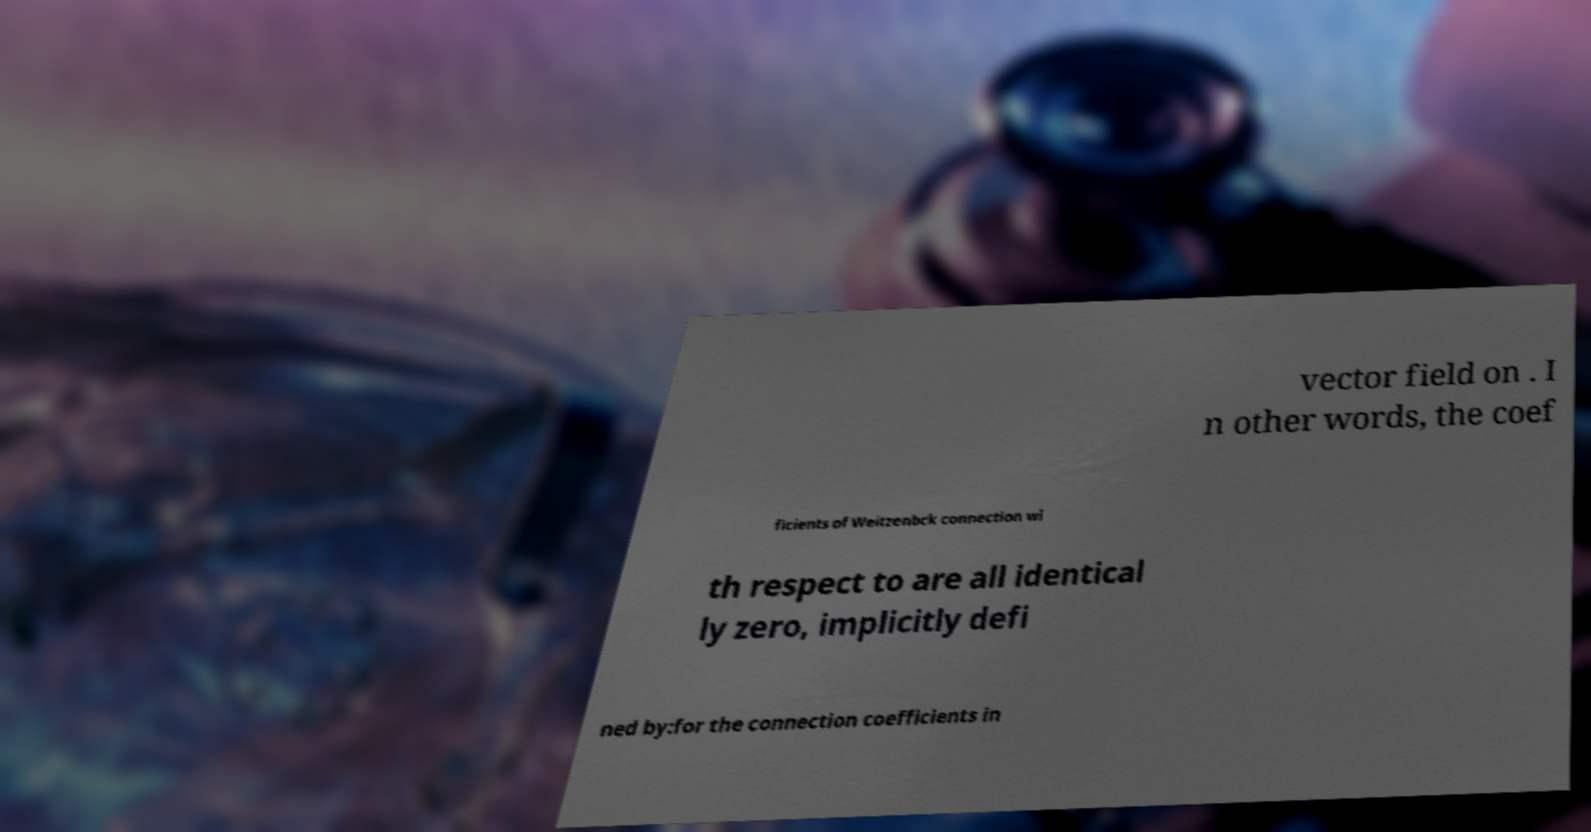Please read and relay the text visible in this image. What does it say? vector field on . I n other words, the coef ficients of Weitzenbck connection wi th respect to are all identical ly zero, implicitly defi ned by:for the connection coefficients in 